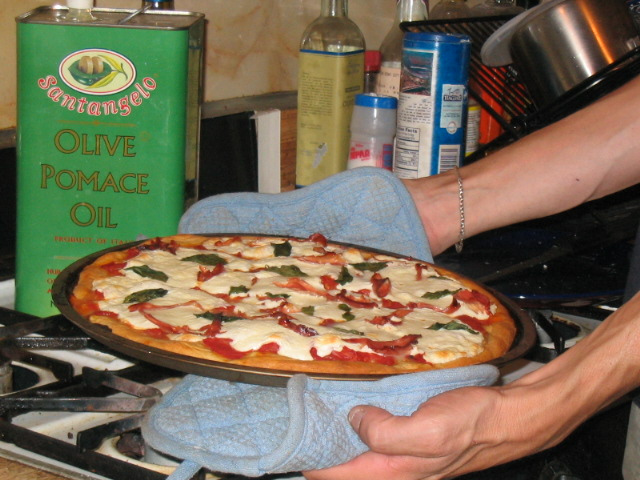Please transcribe the text information in this image. santangelo olive POMACE oil 